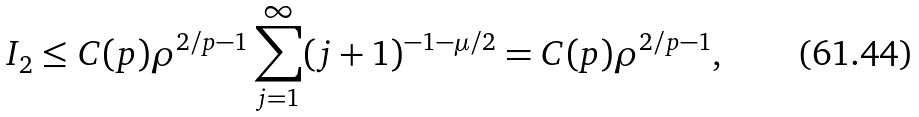Convert formula to latex. <formula><loc_0><loc_0><loc_500><loc_500>I _ { 2 } \leq C ( p ) \rho ^ { 2 / p - 1 } \sum _ { j = 1 } ^ { \infty } ( j + 1 ) ^ { - 1 - \mu / 2 } = C ( p ) \rho ^ { 2 / p - 1 } ,</formula> 